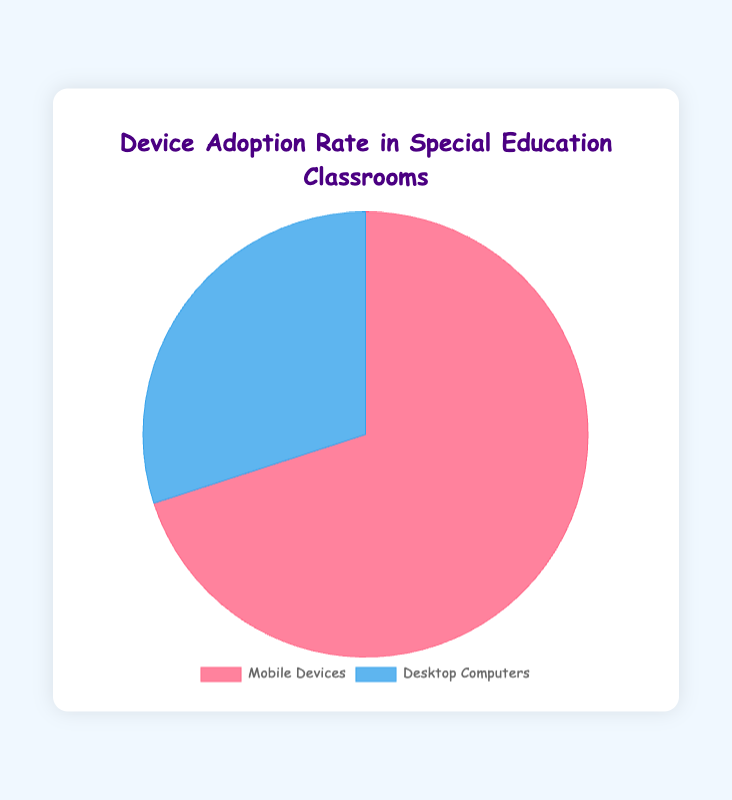What's the percentage of parental involvement in technology-based learning? Look at the section of the pie chart labeled "Technology-Based Learning" to find the percentage.
Answer: 65% What's the percentage of parental involvement in traditional learning? Refer to the section of the pie chart labeled "Traditional Learning" to find the percentage.
Answer: 35% Which learning approach has more parental involvement, technology-based or traditional? Compare the percentages of both sections: 65% for technology-based learning and 35% for traditional learning.
Answer: Technology-Based Learning What's the difference in parental involvement between technology-based learning and traditional learning? Subtract the smaller percentage from the larger one: 65% - 35%.
Answer: 30% What is the combined percentage of parental involvement for both technology-based and traditional learning? Add the percentages of both sections: 65% + 35%.
Answer: 100% Which device type is more widely adopted in special education classrooms, mobile devices or desktop computers? Check the pie chart sections to see that mobile devices have a higher percentage (70%) compared to desktop computers (30%).
Answer: Mobile Devices By how much percent is the adoption rate of mobile devices higher than desktop computers in special education classrooms? Subtract the percentage of desktop computers from mobile devices: 70% - 30%.
Answer: 40% What is the sum of the adoption rates for mobile devices and desktop computers in special education classrooms? Add the percentages of both sections: 70% + 30%.
Answer: 100% What color represents mobile devices in the pie chart for device adoption? Look for the section labeled "Mobile Devices" and note its color in the chart.
Answer: Red What color represents desktop computers in the pie chart for device adoption? Look for the section labeled "Desktop Computers" and note its color in the chart.
Answer: Blue 